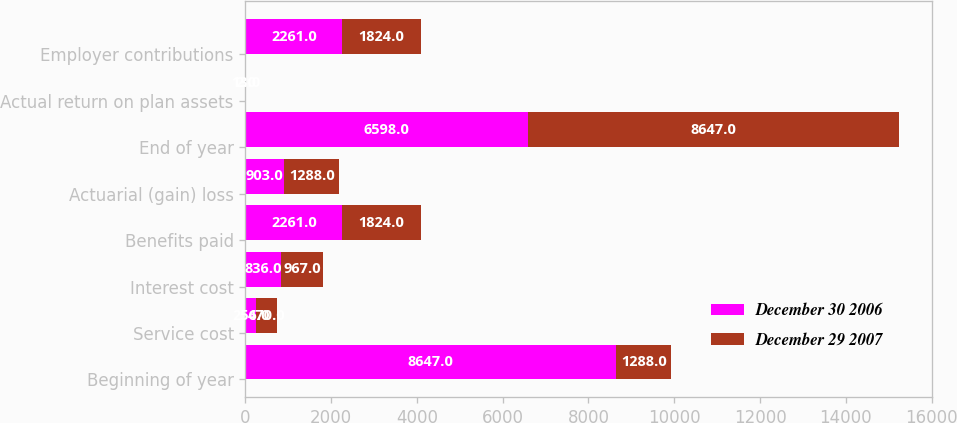Convert chart. <chart><loc_0><loc_0><loc_500><loc_500><stacked_bar_chart><ecel><fcel>Beginning of year<fcel>Service cost<fcel>Interest cost<fcel>Benefits paid<fcel>Actuarial (gain) loss<fcel>End of year<fcel>Actual return on plan assets<fcel>Employer contributions<nl><fcel>December 30 2006<fcel>8647<fcel>256<fcel>836<fcel>2261<fcel>903<fcel>6598<fcel>13<fcel>2261<nl><fcel>December 29 2007<fcel>1288<fcel>470<fcel>967<fcel>1824<fcel>1288<fcel>8647<fcel>2<fcel>1824<nl></chart> 